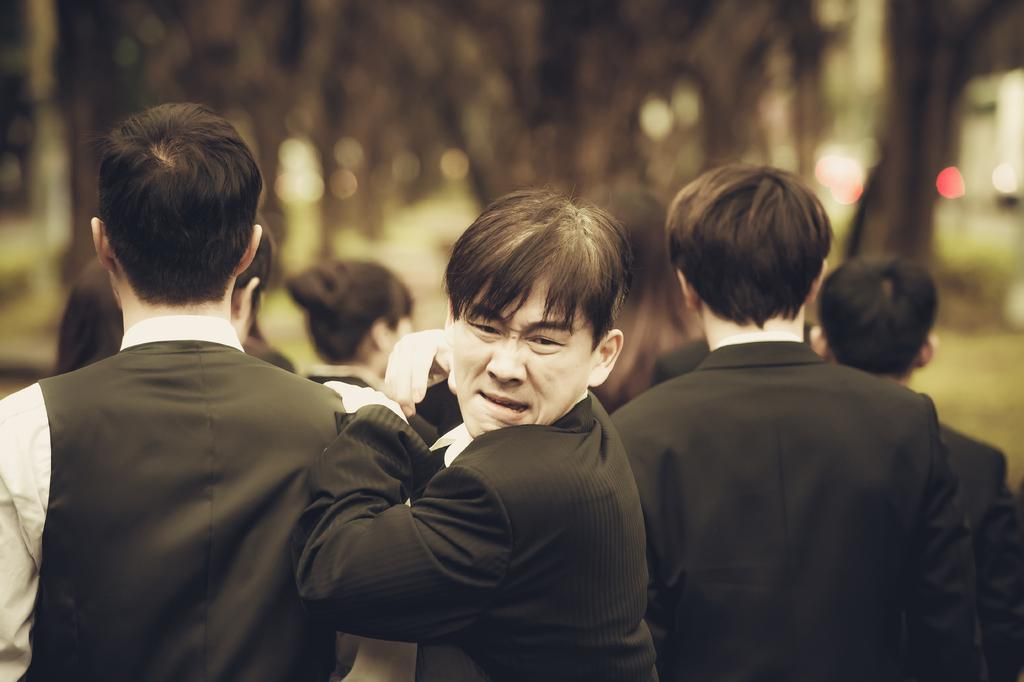How many people are in the image? There are multiple people in the image. What type of clothing are the people wearing? The people are wearing formal dress. Can you describe the background of the image? The background of the image is slightly blurry. What type of support can be seen in the image? There is no support visible in the image. What time of day is depicted in the image? The time of day cannot be determined from the image, as there are no clues about the lighting or time-related elements. 